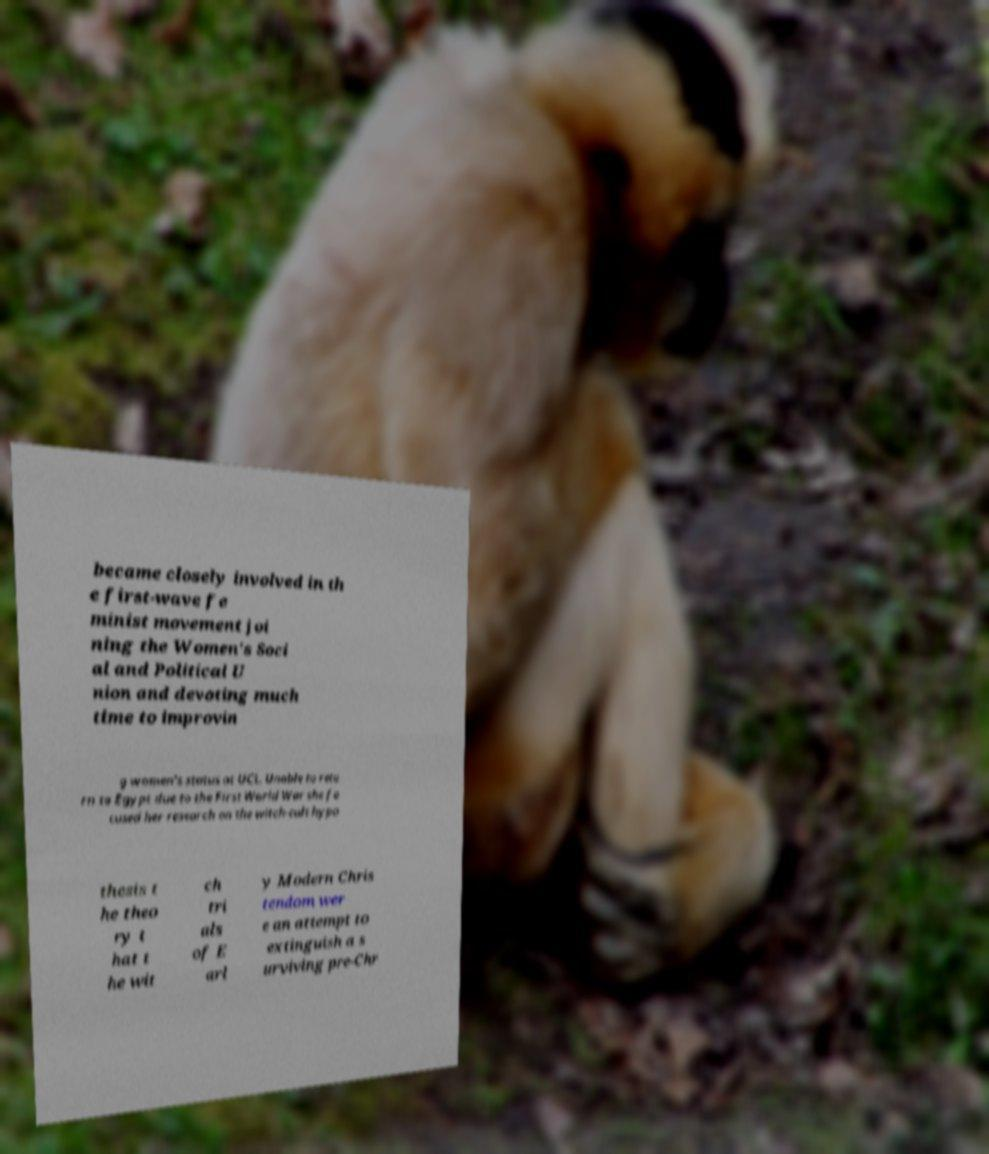Can you accurately transcribe the text from the provided image for me? became closely involved in th e first-wave fe minist movement joi ning the Women's Soci al and Political U nion and devoting much time to improvin g women's status at UCL. Unable to retu rn to Egypt due to the First World War she fo cused her research on the witch-cult hypo thesis t he theo ry t hat t he wit ch tri als of E arl y Modern Chris tendom wer e an attempt to extinguish a s urviving pre-Chr 